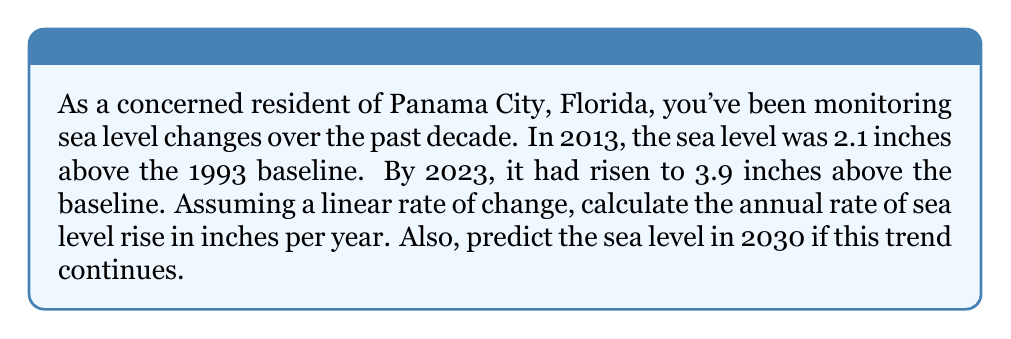Can you solve this math problem? Let's approach this step-by-step using a linear equation:

1) Define variables:
   $x$ = years since 2013
   $y$ = sea level rise in inches (above 1993 baseline)

2) We have two points:
   (0, 2.1) for 2013
   (10, 3.9) for 2023

3) The slope formula for a linear equation is:
   $$m = \frac{y_2 - y_1}{x_2 - x_1} = \frac{3.9 - 2.1}{10 - 0} = \frac{1.8}{10} = 0.18$$

4) This slope, 0.18 inches/year, represents the annual rate of sea level rise.

5) The linear equation is:
   $$y = mx + b$$
   where $b$ is the y-intercept (2.1 in this case)

   So our equation is: $$y = 0.18x + 2.1$$

6) To predict the sea level in 2030:
   2030 is 17 years from 2013, so $x = 17$
   $$y = 0.18(17) + 2.1 = 3.06 + 2.1 = 5.16$$

Therefore, the predicted sea level in 2030 would be 5.16 inches above the 1993 baseline.
Answer: 0.18 inches/year; 5.16 inches above baseline in 2030 